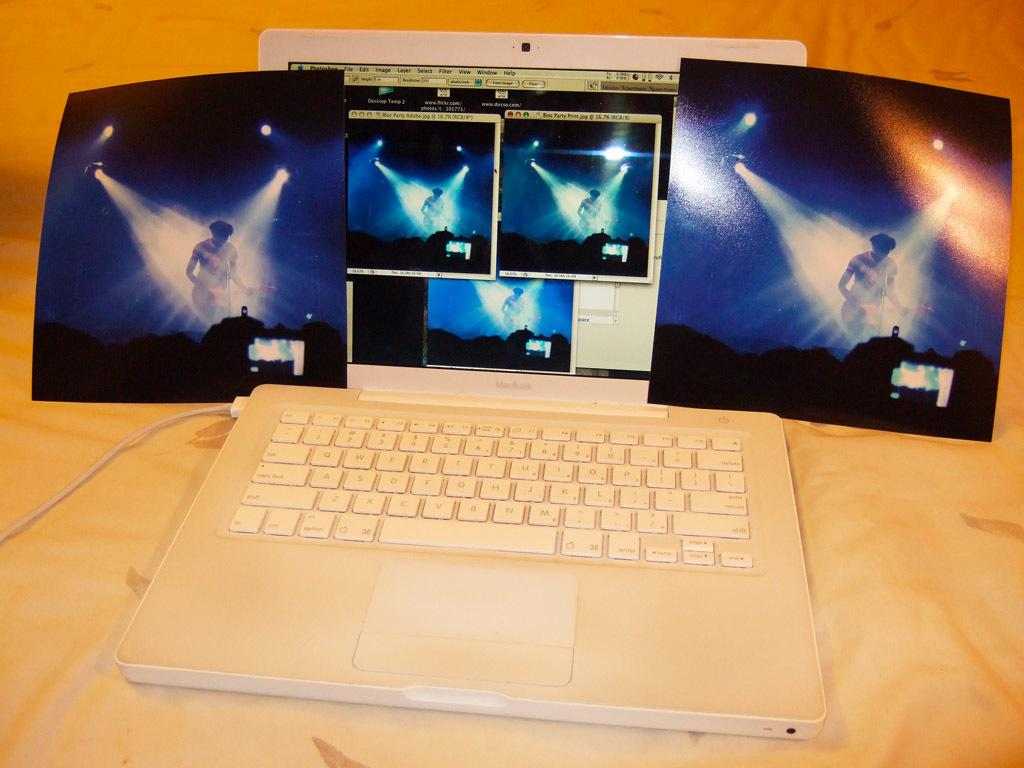<image>
Share a concise interpretation of the image provided. A white Macbook shows shots of a concert on the screen. 